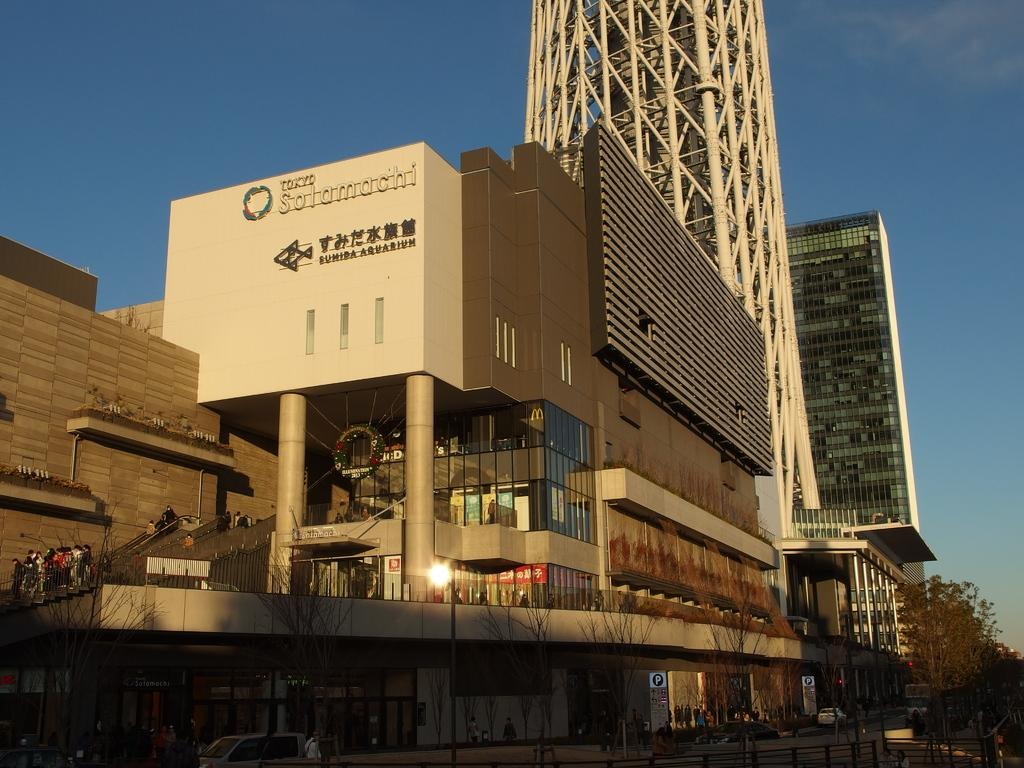What type of structures can be seen in the image? There are buildings in the image. What natural elements are present in the image? There are trees in the image. What man-made feature separates the buildings and trees? There is a fence in the image. What mode of transportation is visible in the image? There are vehicles in the image. Can you describe the people in the image? There is a group of people on the ground in the image. What architectural feature can be seen in the image? There are steps in the image. What can be seen in the distance in the image? The sky is visible in the background of the image. Where is the rifle located in the image? There is no rifle present in the image. What direction are the people facing in the image? The provided facts do not specify the direction the people are facing, so we cannot answer this question definitively. 